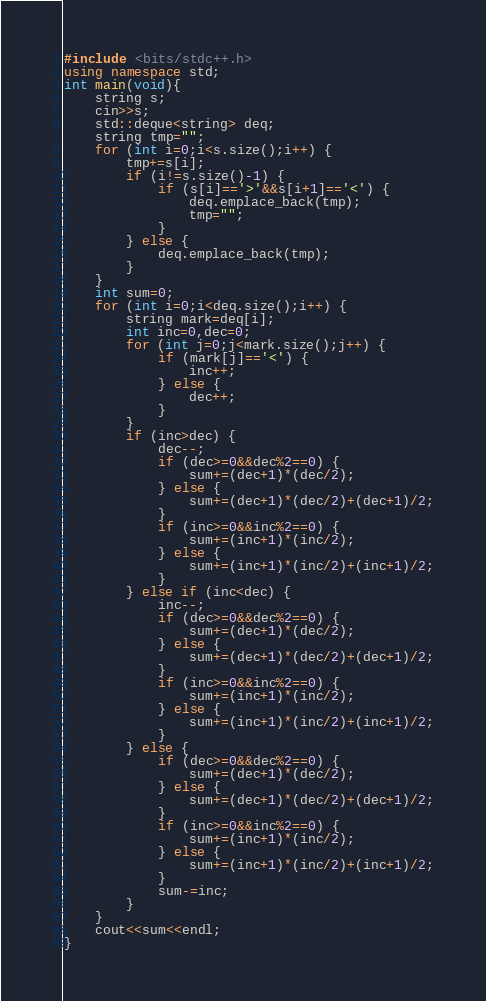Convert code to text. <code><loc_0><loc_0><loc_500><loc_500><_C++_>#include <bits/stdc++.h>
using namespace std;
int main(void){
    string s;
    cin>>s;
    std::deque<string> deq;
    string tmp="";
    for (int i=0;i<s.size();i++) {
        tmp+=s[i];
        if (i!=s.size()-1) {
            if (s[i]=='>'&&s[i+1]=='<') {
                deq.emplace_back(tmp);
                tmp="";
            }
        } else {
            deq.emplace_back(tmp);
        }
    }
    int sum=0;
    for (int i=0;i<deq.size();i++) {
        string mark=deq[i];
        int inc=0,dec=0;
        for (int j=0;j<mark.size();j++) {
            if (mark[j]=='<') {
                inc++;
            } else {
                dec++;
            }
        }
        if (inc>dec) {
            dec--;
            if (dec>=0&&dec%2==0) {
                sum+=(dec+1)*(dec/2);
            } else {
                sum+=(dec+1)*(dec/2)+(dec+1)/2;
            }
            if (inc>=0&&inc%2==0) {
                sum+=(inc+1)*(inc/2);
            } else {
                sum+=(inc+1)*(inc/2)+(inc+1)/2;
            }
        } else if (inc<dec) {
            inc--;
            if (dec>=0&&dec%2==0) {
                sum+=(dec+1)*(dec/2);
            } else {
                sum+=(dec+1)*(dec/2)+(dec+1)/2;
            }
            if (inc>=0&&inc%2==0) {
                sum+=(inc+1)*(inc/2);
            } else {
                sum+=(inc+1)*(inc/2)+(inc+1)/2;
            }
        } else {
            if (dec>=0&&dec%2==0) {
                sum+=(dec+1)*(dec/2);
            } else {
                sum+=(dec+1)*(dec/2)+(dec+1)/2;
            }
            if (inc>=0&&inc%2==0) {
                sum+=(inc+1)*(inc/2);
            } else {
                sum+=(inc+1)*(inc/2)+(inc+1)/2;
            }
            sum-=inc;
        }
    }
    cout<<sum<<endl;
}</code> 